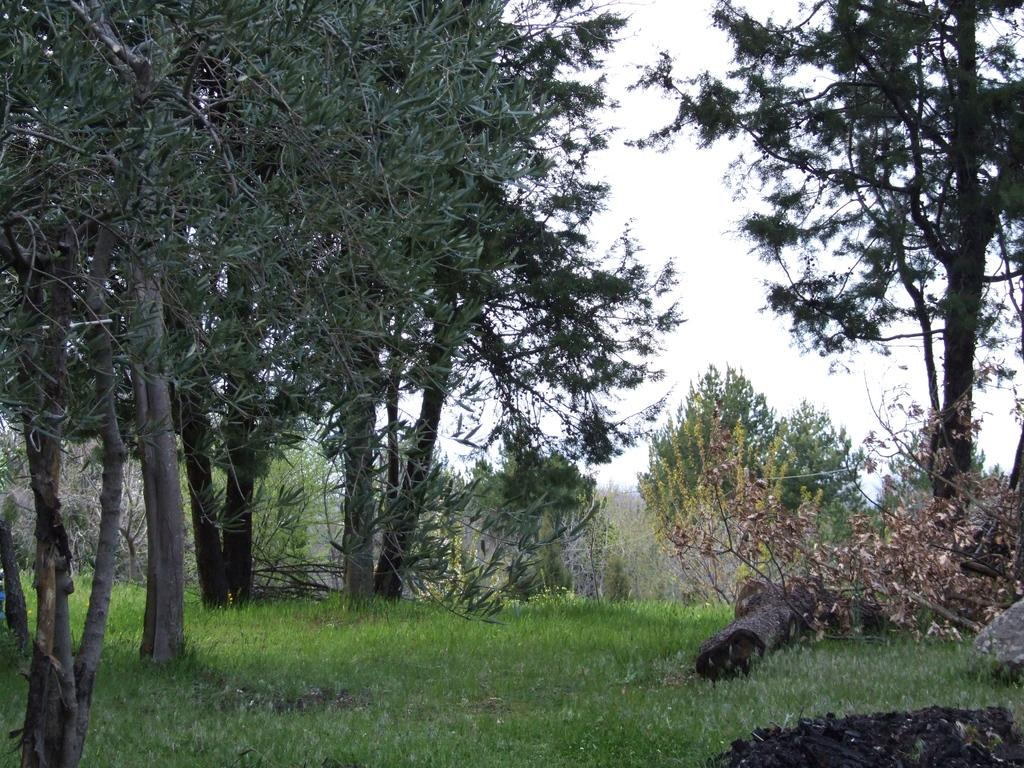What is on the ground in the image? There are logs on the ground in the image. What type of vegetation can be seen in the image? There are plants and trees in the image. What part of the natural environment is visible in the image? The sky is visible in the image. What type of lunch is being served in the image? There is no lunch present in the image; it features logs, plants, trees, and the sky. Can you describe the argument taking place between the trees in the image? There is no argument between the trees in the image; they are stationary and not engaged in any activity. 